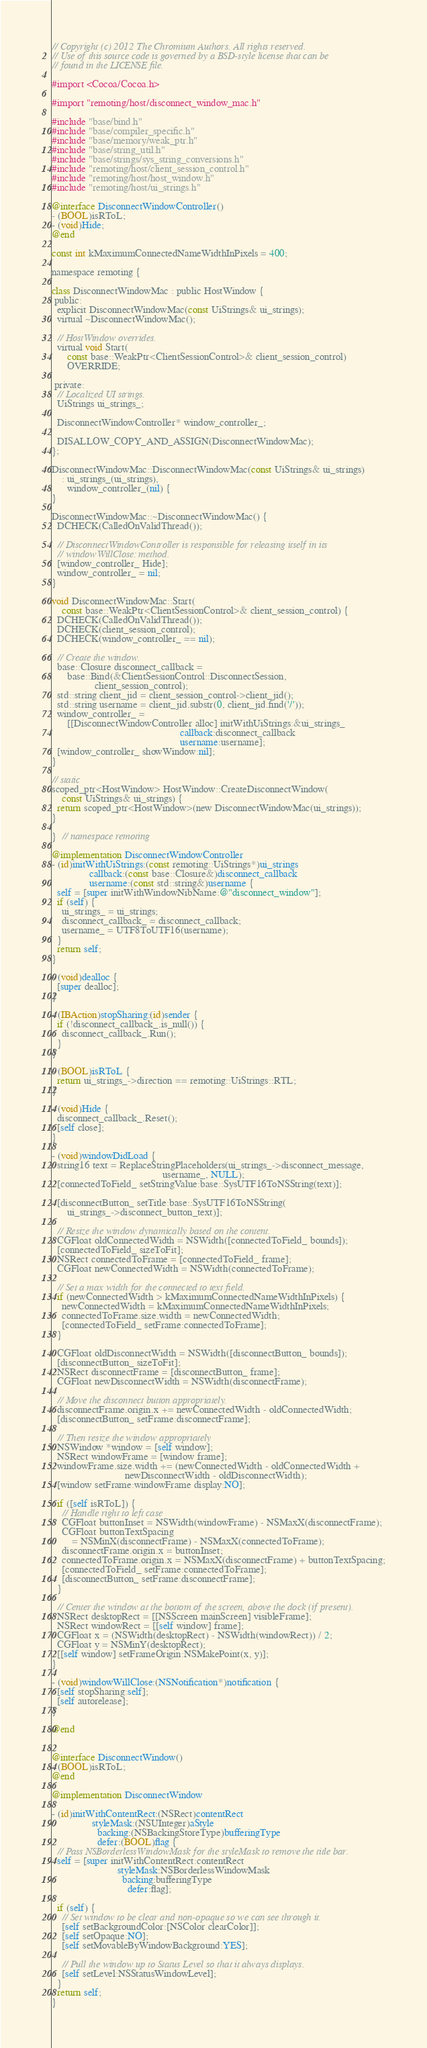Convert code to text. <code><loc_0><loc_0><loc_500><loc_500><_ObjectiveC_>// Copyright (c) 2012 The Chromium Authors. All rights reserved.
// Use of this source code is governed by a BSD-style license that can be
// found in the LICENSE file.

#import <Cocoa/Cocoa.h>

#import "remoting/host/disconnect_window_mac.h"

#include "base/bind.h"
#include "base/compiler_specific.h"
#include "base/memory/weak_ptr.h"
#include "base/string_util.h"
#include "base/strings/sys_string_conversions.h"
#include "remoting/host/client_session_control.h"
#include "remoting/host/host_window.h"
#include "remoting/host/ui_strings.h"

@interface DisconnectWindowController()
- (BOOL)isRToL;
- (void)Hide;
@end

const int kMaximumConnectedNameWidthInPixels = 400;

namespace remoting {

class DisconnectWindowMac : public HostWindow {
 public:
  explicit DisconnectWindowMac(const UiStrings& ui_strings);
  virtual ~DisconnectWindowMac();

  // HostWindow overrides.
  virtual void Start(
      const base::WeakPtr<ClientSessionControl>& client_session_control)
      OVERRIDE;

 private:
  // Localized UI strings.
  UiStrings ui_strings_;

  DisconnectWindowController* window_controller_;

  DISALLOW_COPY_AND_ASSIGN(DisconnectWindowMac);
};

DisconnectWindowMac::DisconnectWindowMac(const UiStrings& ui_strings)
    : ui_strings_(ui_strings),
      window_controller_(nil) {
}

DisconnectWindowMac::~DisconnectWindowMac() {
  DCHECK(CalledOnValidThread());

  // DisconnectWindowController is responsible for releasing itself in its
  // windowWillClose: method.
  [window_controller_ Hide];
  window_controller_ = nil;
}

void DisconnectWindowMac::Start(
    const base::WeakPtr<ClientSessionControl>& client_session_control) {
  DCHECK(CalledOnValidThread());
  DCHECK(client_session_control);
  DCHECK(window_controller_ == nil);

  // Create the window.
  base::Closure disconnect_callback =
      base::Bind(&ClientSessionControl::DisconnectSession,
                 client_session_control);
  std::string client_jid = client_session_control->client_jid();
  std::string username = client_jid.substr(0, client_jid.find('/'));
  window_controller_ =
      [[DisconnectWindowController alloc] initWithUiStrings:&ui_strings_
                                                   callback:disconnect_callback
                                                   username:username];
  [window_controller_ showWindow:nil];
}

// static
scoped_ptr<HostWindow> HostWindow::CreateDisconnectWindow(
    const UiStrings& ui_strings) {
  return scoped_ptr<HostWindow>(new DisconnectWindowMac(ui_strings));
}

}  // namespace remoting

@implementation DisconnectWindowController
- (id)initWithUiStrings:(const remoting::UiStrings*)ui_strings
               callback:(const base::Closure&)disconnect_callback
               username:(const std::string&)username {
  self = [super initWithWindowNibName:@"disconnect_window"];
  if (self) {
    ui_strings_ = ui_strings;
    disconnect_callback_ = disconnect_callback;
    username_ = UTF8ToUTF16(username);
  }
  return self;
}

- (void)dealloc {
  [super dealloc];
}

- (IBAction)stopSharing:(id)sender {
  if (!disconnect_callback_.is_null()) {
    disconnect_callback_.Run();
  }
}

- (BOOL)isRToL {
  return ui_strings_->direction == remoting::UiStrings::RTL;
}

- (void)Hide {
  disconnect_callback_.Reset();
  [self close];
}

- (void)windowDidLoad {
  string16 text = ReplaceStringPlaceholders(ui_strings_->disconnect_message,
                                            username_, NULL);
  [connectedToField_ setStringValue:base::SysUTF16ToNSString(text)];

  [disconnectButton_ setTitle:base::SysUTF16ToNSString(
      ui_strings_->disconnect_button_text)];

  // Resize the window dynamically based on the content.
  CGFloat oldConnectedWidth = NSWidth([connectedToField_ bounds]);
  [connectedToField_ sizeToFit];
  NSRect connectedToFrame = [connectedToField_ frame];
  CGFloat newConnectedWidth = NSWidth(connectedToFrame);

  // Set a max width for the connected to text field.
  if (newConnectedWidth > kMaximumConnectedNameWidthInPixels) {
    newConnectedWidth = kMaximumConnectedNameWidthInPixels;
    connectedToFrame.size.width = newConnectedWidth;
    [connectedToField_ setFrame:connectedToFrame];
  }

  CGFloat oldDisconnectWidth = NSWidth([disconnectButton_ bounds]);
  [disconnectButton_ sizeToFit];
  NSRect disconnectFrame = [disconnectButton_ frame];
  CGFloat newDisconnectWidth = NSWidth(disconnectFrame);

  // Move the disconnect button appropriately.
  disconnectFrame.origin.x += newConnectedWidth - oldConnectedWidth;
  [disconnectButton_ setFrame:disconnectFrame];

  // Then resize the window appropriately
  NSWindow *window = [self window];
  NSRect windowFrame = [window frame];
  windowFrame.size.width += (newConnectedWidth - oldConnectedWidth +
                             newDisconnectWidth - oldDisconnectWidth);
  [window setFrame:windowFrame display:NO];

  if ([self isRToL]) {
    // Handle right to left case
    CGFloat buttonInset = NSWidth(windowFrame) - NSMaxX(disconnectFrame);
    CGFloat buttonTextSpacing
        = NSMinX(disconnectFrame) - NSMaxX(connectedToFrame);
    disconnectFrame.origin.x = buttonInset;
    connectedToFrame.origin.x = NSMaxX(disconnectFrame) + buttonTextSpacing;
    [connectedToField_ setFrame:connectedToFrame];
    [disconnectButton_ setFrame:disconnectFrame];
  }

  // Center the window at the bottom of the screen, above the dock (if present).
  NSRect desktopRect = [[NSScreen mainScreen] visibleFrame];
  NSRect windowRect = [[self window] frame];
  CGFloat x = (NSWidth(desktopRect) - NSWidth(windowRect)) / 2;
  CGFloat y = NSMinY(desktopRect);
  [[self window] setFrameOrigin:NSMakePoint(x, y)];
}

- (void)windowWillClose:(NSNotification*)notification {
  [self stopSharing:self];
  [self autorelease];
}

@end


@interface DisconnectWindow()
- (BOOL)isRToL;
@end

@implementation DisconnectWindow

- (id)initWithContentRect:(NSRect)contentRect
                styleMask:(NSUInteger)aStyle
                  backing:(NSBackingStoreType)bufferingType
                  defer:(BOOL)flag {
  // Pass NSBorderlessWindowMask for the styleMask to remove the title bar.
  self = [super initWithContentRect:contentRect
                          styleMask:NSBorderlessWindowMask
                            backing:bufferingType
                              defer:flag];

  if (self) {
    // Set window to be clear and non-opaque so we can see through it.
    [self setBackgroundColor:[NSColor clearColor]];
    [self setOpaque:NO];
    [self setMovableByWindowBackground:YES];

    // Pull the window up to Status Level so that it always displays.
    [self setLevel:NSStatusWindowLevel];
  }
  return self;
}
</code> 